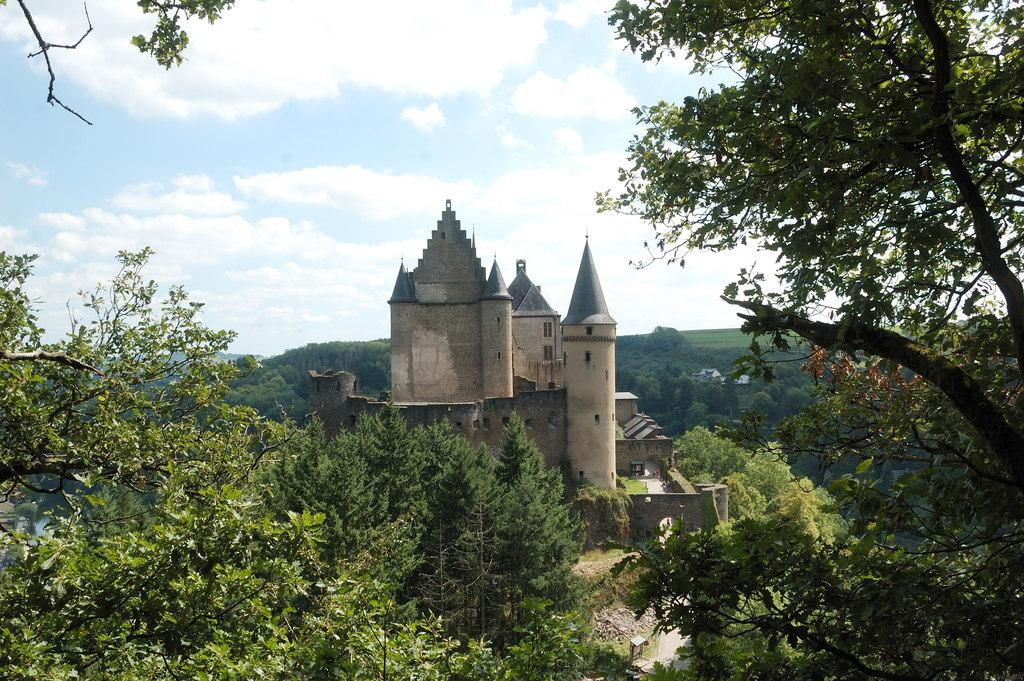What type of vegetation is present in the image? There are many trees in the image. What natural element can be seen alongside the trees? There is water visible in the image. What type of structure is present in the image? There is a castle in the image. What type of terrain is visible in the image? There is grassland in the image. What is visible in the background of the image? The sky is visible in the background of the image, and there are clouds in the sky. What type of class is being taught in the image? There is no class or teaching activity present in the image. How does the carpenter balance the tools in the image? There is no carpenter or tools present in the image. 